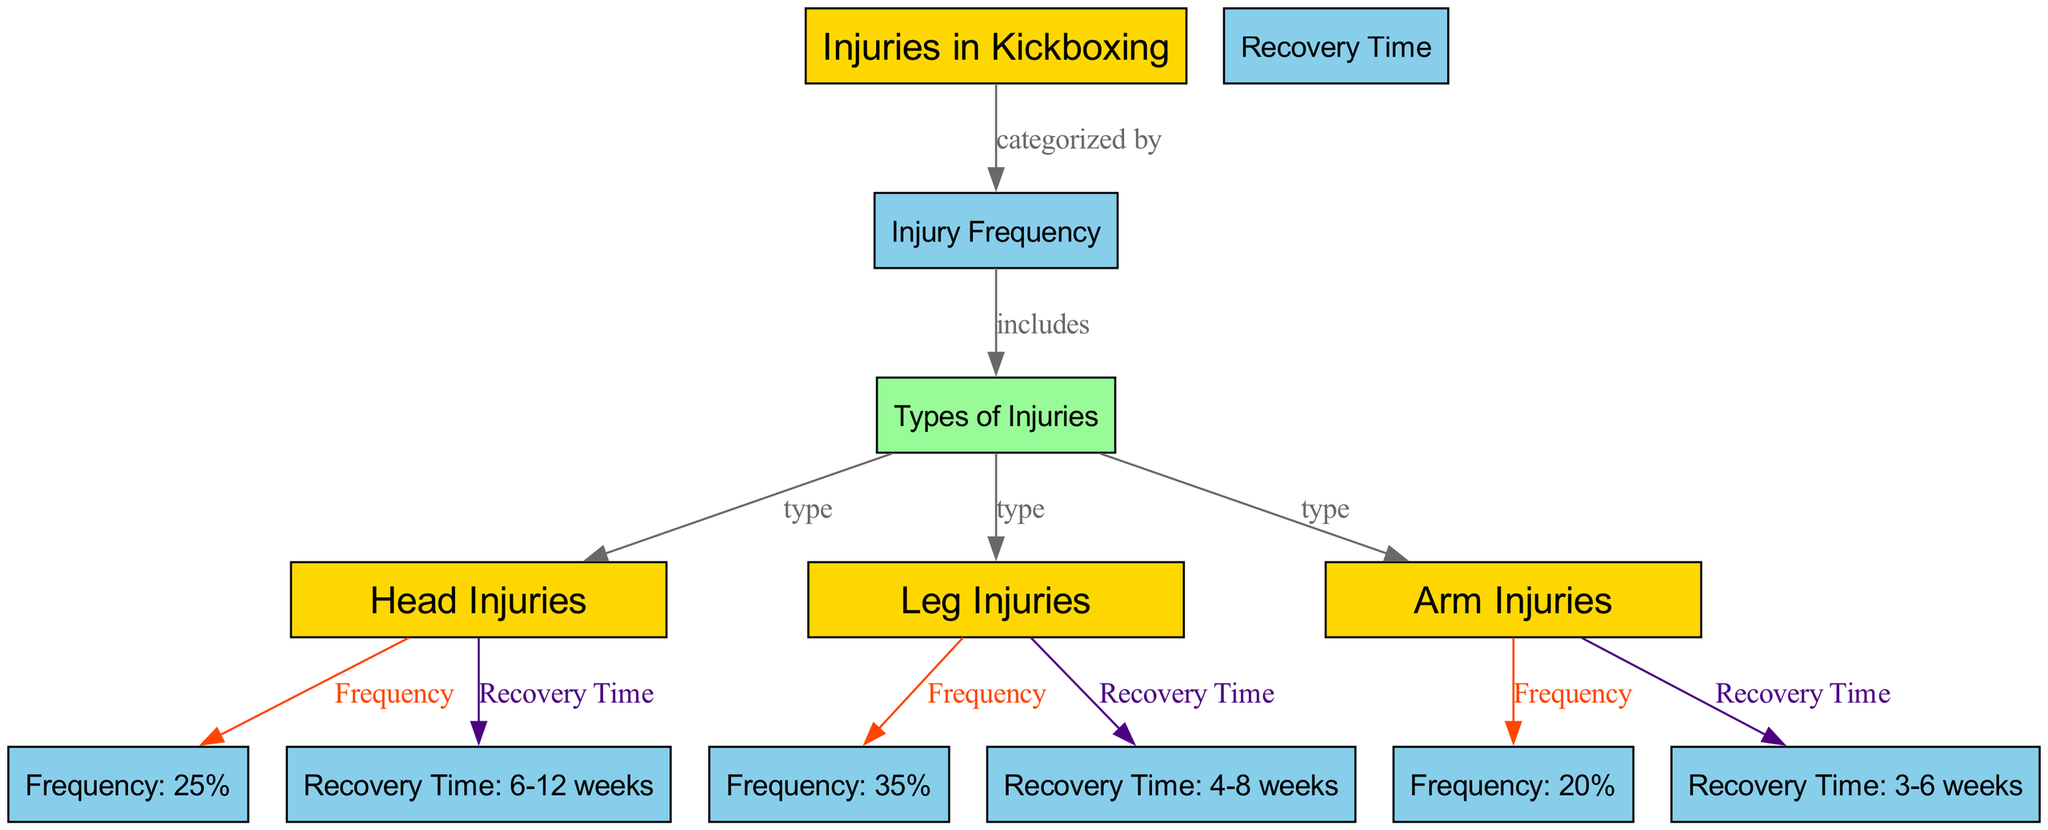What are the types of injuries included in the diagram? The diagram identifies three specific types of injuries associated with kickboxing: head injuries, leg injuries, and arm injuries. These are directly connected under the "Types of Injuries" node.
Answer: head injuries, leg injuries, arm injuries What is the frequency of leg injuries reported in the diagram? The leg injuries node has an edge pointing to the "Frequency: 35%" node, indicating that 35% of all injuries in kickboxing are leg injuries.
Answer: 35% How many edges are present in the diagram? Counting the relationships expressed by the edges, we see there are a total of 11 edges connecting various nodes within the diagram.
Answer: 11 What is the recovery time for head injuries? The head injuries node is linked to the "Recovery Time: 6-12 weeks" node, which specifies the recovery duration needed for head injuries.
Answer: 6-12 weeks Which type of injury has the shortest recovery time? By comparing the recovery times for the three types of injuries shown, we see that arm injuries have the shortest recovery time of 3-6 weeks.
Answer: arm injuries What is the relationship between injury frequency and types of injuries? The "Injury Frequency" node categorizes injuries, and the "Types of Injuries" node includes specific types. This flow indicates that injury frequency impacts the classification of injury types.
Answer: categorized by What is the total percentage of head and arm injuries? Adding the frequencies of head injuries (25%) and arm injuries (20%), we find that 45% of the injuries fall under these two categories together.
Answer: 45% Which color represents the frequency nodes in the diagram? The frequency nodes are represented in a light blue color corresponding to the fill color '#87CEEB' specified in the diagram definition.
Answer: light blue What is the longest reported recovery time among the injuries? By examining the recovery times associated with the types of injuries, we find that head injuries take the longest recovery time, which is 6-12 weeks.
Answer: 6-12 weeks 